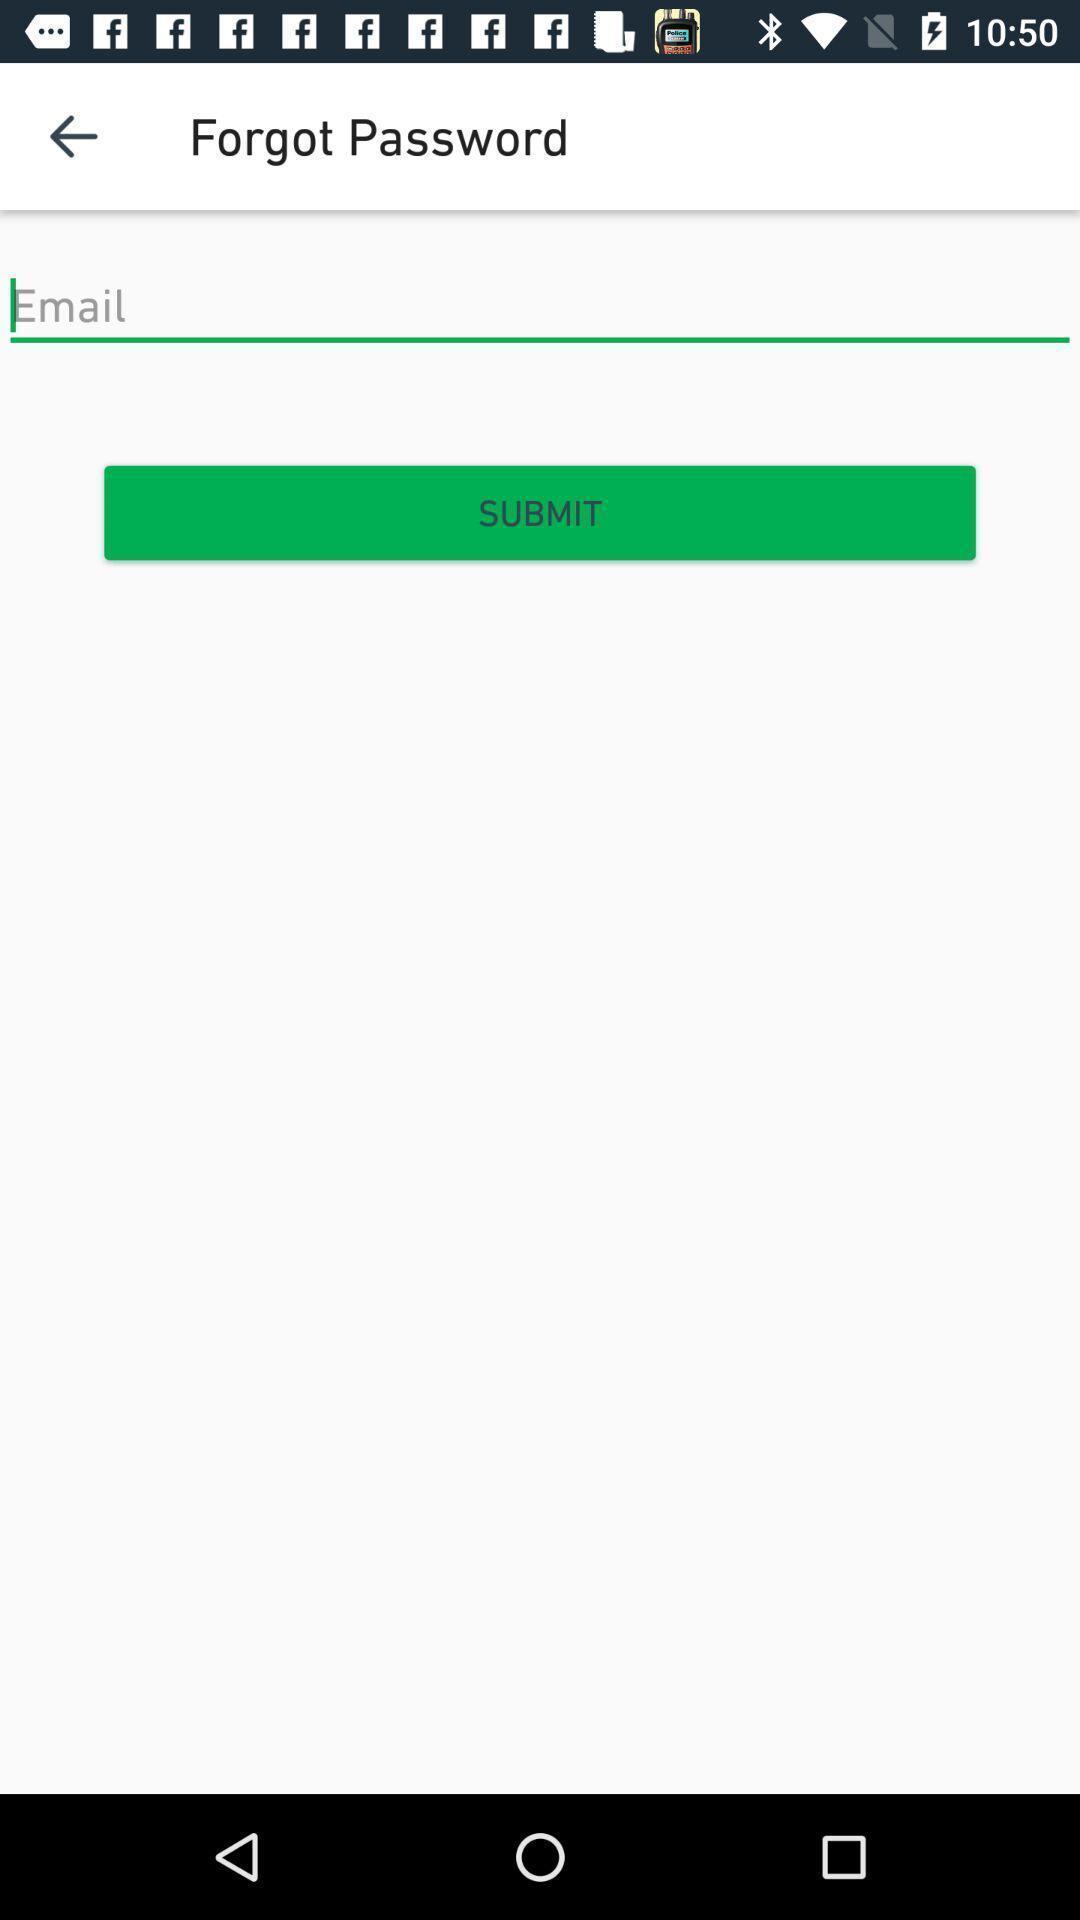Describe the key features of this screenshot. Page showing forgot password. 